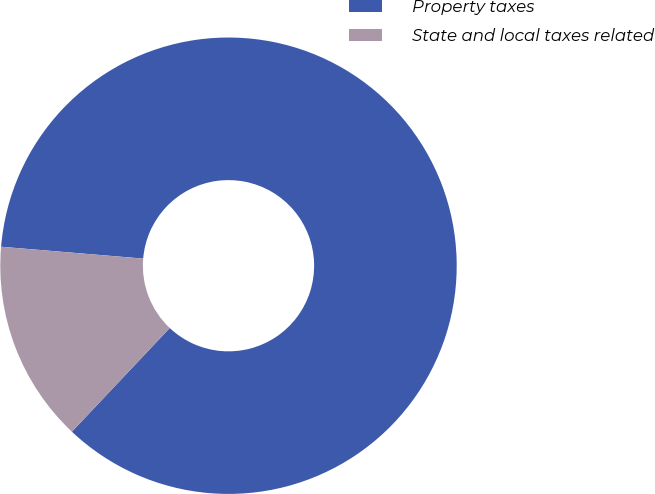Convert chart to OTSL. <chart><loc_0><loc_0><loc_500><loc_500><pie_chart><fcel>Property taxes<fcel>State and local taxes related<nl><fcel>85.71%<fcel>14.29%<nl></chart> 